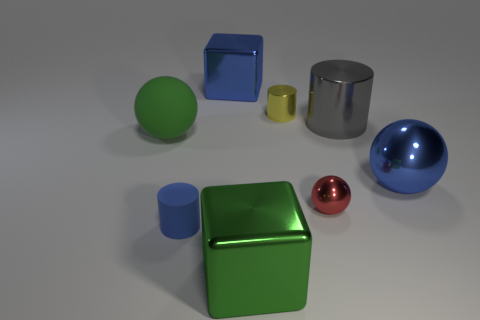Do the big metallic ball and the cylinder that is to the left of the small metallic cylinder have the same color? yes 